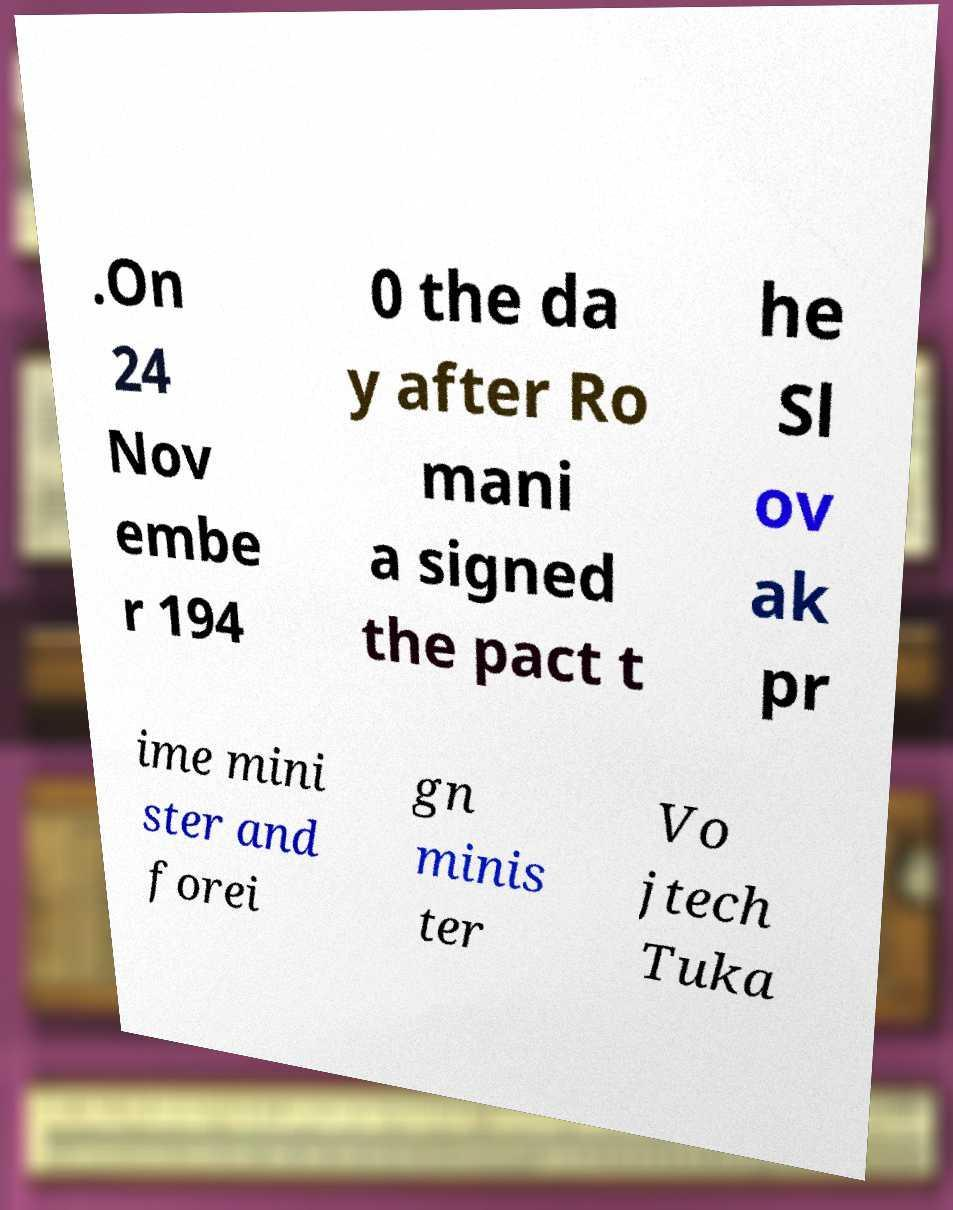There's text embedded in this image that I need extracted. Can you transcribe it verbatim? .On 24 Nov embe r 194 0 the da y after Ro mani a signed the pact t he Sl ov ak pr ime mini ster and forei gn minis ter Vo jtech Tuka 